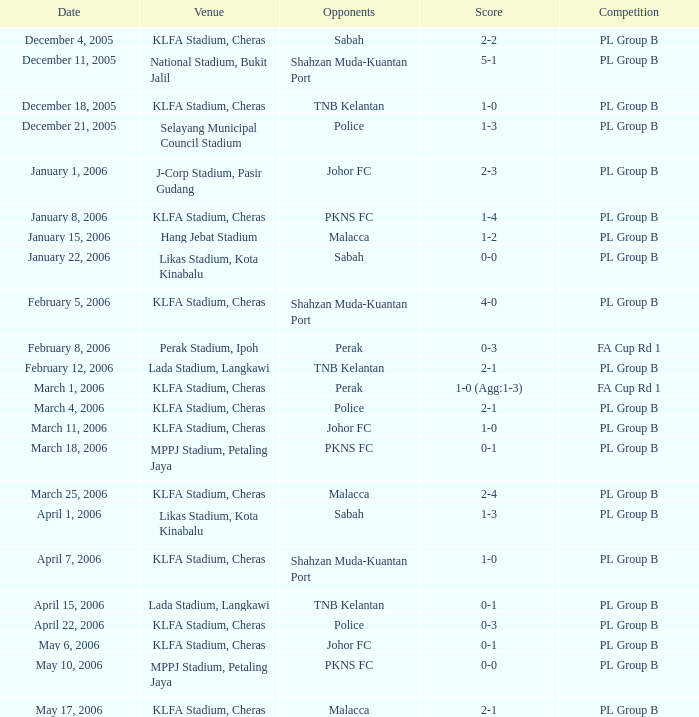Which tournament features rivals of pkns fc, and a scoreline of 0-0? PL Group B. 